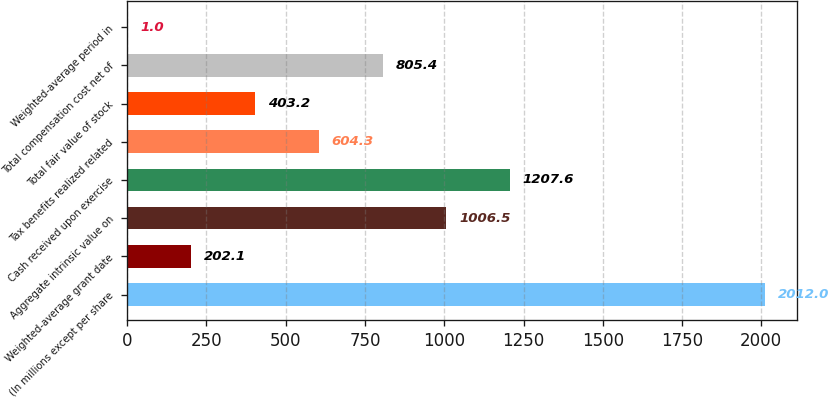Convert chart. <chart><loc_0><loc_0><loc_500><loc_500><bar_chart><fcel>(In millions except per share<fcel>Weighted-average grant date<fcel>Aggregate intrinsic value on<fcel>Cash received upon exercise<fcel>Tax benefits realized related<fcel>Total fair value of stock<fcel>Total compensation cost net of<fcel>Weighted-average period in<nl><fcel>2012<fcel>202.1<fcel>1006.5<fcel>1207.6<fcel>604.3<fcel>403.2<fcel>805.4<fcel>1<nl></chart> 